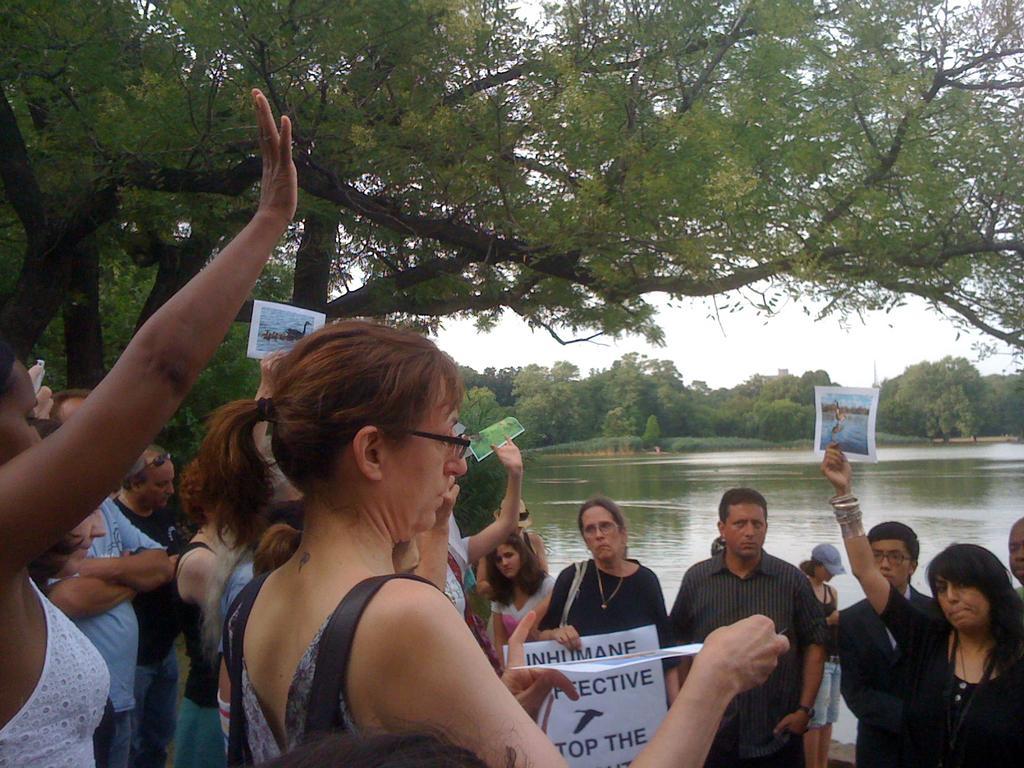Could you give a brief overview of what you see in this image? In this picture, we see the people are standing and they are holding the papers in their hands. The woman in front of the picture wearing the spectacles is holding a paper or a poster. The woman in the middle who is wearing the black dress is holding a banner or a board in white color with some text written on it. Behind them, we see water and this water might be in the pond. On the left side, we see the trees. There are trees in the background. We even see the sky. 